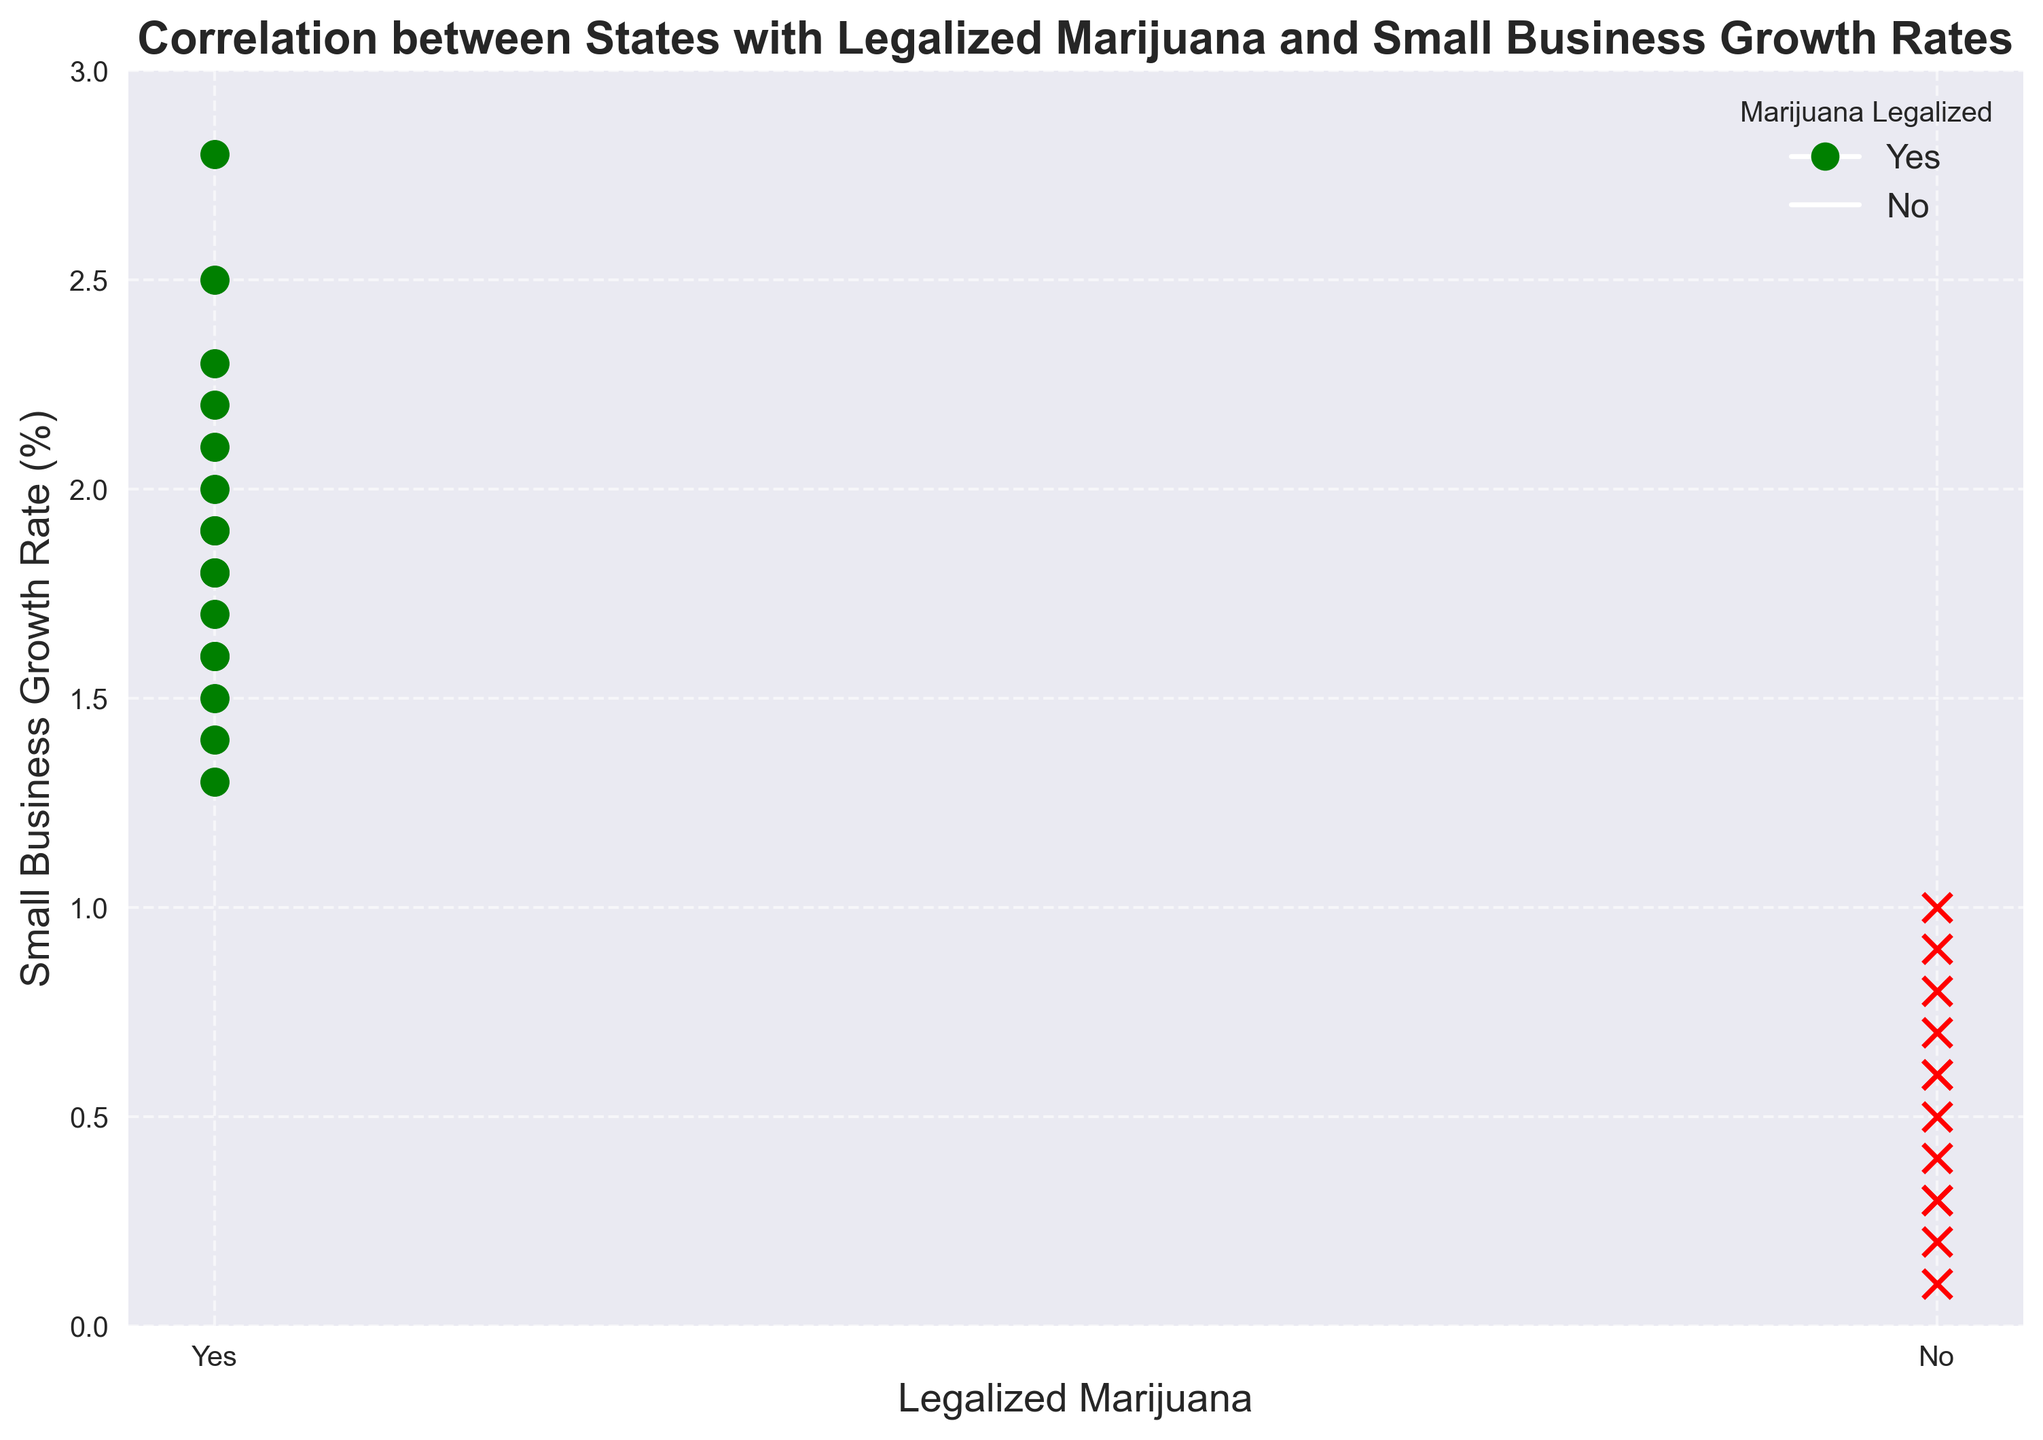Which states have legalized marijuana in the plot? The green markers indicate the states with legalized marijuana. Observing the green markers in the plot, the states are California, Colorado, Washington, Oregon, Nevada, Massachusetts, Maine, Alaska, Illinois, Michigan, Arizona, Montana, Vermont, New Jersey, New York, and Virginia.
Answer: California, Colorado, Washington, Oregon, Nevada, Massachusetts, Maine, Alaska, Illinois, Michigan, Arizona, Montana, Vermont, New Jersey, New York, Virginia What is the range of small business growth rates for states with legalized marijuana? Examining the green markers (Yes) on the y-axis, the small business growth rates for states with legalized marijuana range from 1.3% to 2.8%.
Answer: 1.3% to 2.8% What is the difference in small business growth rates between California and Texas? California (green 'Yes' marker) has a growth rate of 2.5%, and Texas (red 'No' marker) has a growth rate of 0.9%. The difference can be calculated as 2.5% - 0.9%.
Answer: 1.6% Which state with legalized marijuana has the lowest small business growth rate? Looking at the green markers (Yes) on the y-axis and identifying the lowest green mark, we find Vermont with a growth rate of 1.3%.
Answer: Vermont Is there a state without legalized marijuana that has higher small business growth rates than any of the states with legalized marijuana? Observing the red (No) and green (Yes) marks on the y-axis, the highest red mark (Florida) has a growth rate of 1.0%, which is lower than the lowest green mark (Vermont) at 1.3%.
Answer: No How many states without legalized marijuana have a growth rate of 0.5% or below? Looking at the red (No) markers on the y-axis, identify those at or below 0.5%. Alabama, Mississippi, Idaho, Wyoming, South Carolina, and Kentucky fall in this range. There are 6 such states.
Answer: 6 What is the small business growth rate for Colorado? Colorado is a green marker (Yes) and its growth rate is positioned at 2.8% on the y-axis.
Answer: 2.8% Which states with legalized marijuana have a growth rate between 2.0% and 3.0%? Look at the green markers (Yes) within the range of 2.0% and 3.0% on the y-axis. These states are California, Colorado, Washington, Oregon, Nevada, and New Jersey.
Answer: California, Colorado, Washington, Oregon, Nevada, New Jersey What overall trend do you observe regarding marijuana legalization and small business growth rate? Compare the green (Yes) markers with the red (No) markers on the y-axis. States with legalized marijuana (green) tend to have higher small business growth rates, mostly above 1.3%, while states without legalized marijuana (red) have lower growth rates, mostly below 1.0%.
Answer: States with legalized marijuana tend to have higher small business growth rates 